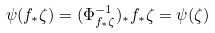Convert formula to latex. <formula><loc_0><loc_0><loc_500><loc_500>\psi ( f _ { \ast } \zeta ) = ( \Phi _ { f _ { \ast } \zeta } ^ { - 1 } ) _ { \ast } f _ { \ast } \zeta = \psi ( \zeta )</formula> 